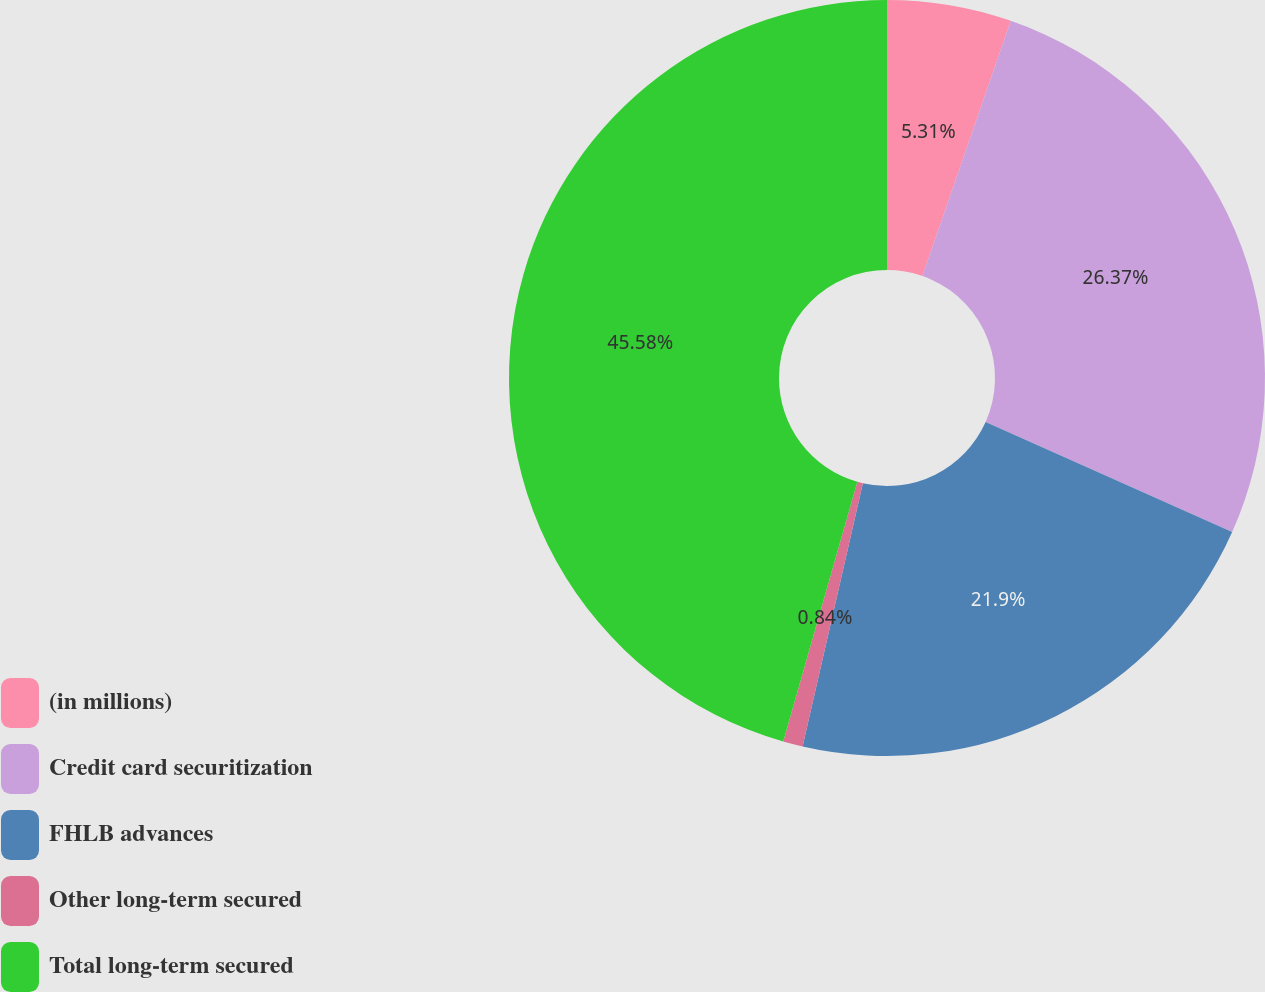Convert chart to OTSL. <chart><loc_0><loc_0><loc_500><loc_500><pie_chart><fcel>(in millions)<fcel>Credit card securitization<fcel>FHLB advances<fcel>Other long-term secured<fcel>Total long-term secured<nl><fcel>5.31%<fcel>26.37%<fcel>21.9%<fcel>0.84%<fcel>45.57%<nl></chart> 